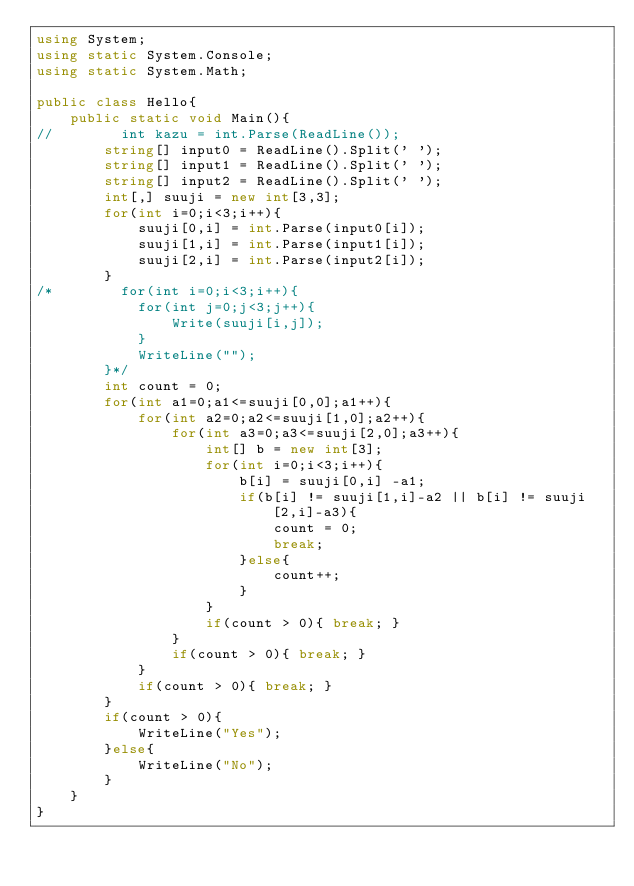<code> <loc_0><loc_0><loc_500><loc_500><_C#_>using System;
using static System.Console;
using static System.Math;

public class Hello{
    public static void Main(){
//        int kazu = int.Parse(ReadLine());
        string[] input0 = ReadLine().Split(' ');
        string[] input1 = ReadLine().Split(' ');
        string[] input2 = ReadLine().Split(' ');
        int[,] suuji = new int[3,3];
        for(int i=0;i<3;i++){
            suuji[0,i] = int.Parse(input0[i]);
            suuji[1,i] = int.Parse(input1[i]);
            suuji[2,i] = int.Parse(input2[i]);
        }
/*        for(int i=0;i<3;i++){
            for(int j=0;j<3;j++){
                Write(suuji[i,j]);
            }
            WriteLine("");
        }*/
        int count = 0;
        for(int a1=0;a1<=suuji[0,0];a1++){
            for(int a2=0;a2<=suuji[1,0];a2++){
                for(int a3=0;a3<=suuji[2,0];a3++){
                    int[] b = new int[3];
                    for(int i=0;i<3;i++){
                        b[i] = suuji[0,i] -a1;
                        if(b[i] != suuji[1,i]-a2 || b[i] != suuji[2,i]-a3){
                            count = 0;
                            break;
                        }else{
                            count++;
                        }
                    }
                    if(count > 0){ break; }
                }
                if(count > 0){ break; }
            }
            if(count > 0){ break; }
        }
        if(count > 0){
            WriteLine("Yes");
        }else{
            WriteLine("No");
        }
    }
}
</code> 